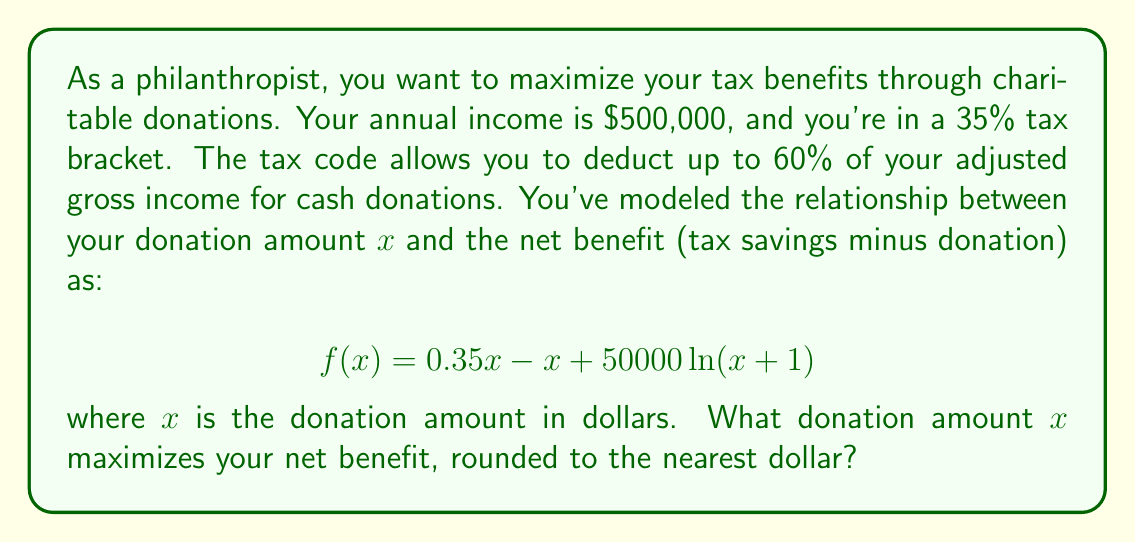Can you answer this question? To find the optimal donation amount, we need to maximize the function $f(x)$. This can be done by finding the value of $x$ where the derivative of $f(x)$ equals zero.

1) First, let's find the derivative of $f(x)$:
   $$ f'(x) = 0.35 - 1 + \frac{50000}{x+1} $$

2) Set the derivative equal to zero and solve for $x$:
   $$ 0.35 - 1 + \frac{50000}{x+1} = 0 $$
   $$ \frac{50000}{x+1} = 0.65 $$
   $$ 50000 = 0.65(x+1) $$
   $$ 76923.08 = x+1 $$
   $$ x = 75922.08 $$

3) To confirm this is a maximum, we can check the second derivative:
   $$ f''(x) = -\frac{50000}{(x+1)^2} $$
   This is always negative, confirming we have a maximum.

4) We need to check if this amount is within the allowable 60% of income:
   $$ 60\% \text{ of } \$500,000 = \$300,000 $$
   Our calculated optimal amount is less than this, so it's allowable.

5) Rounding to the nearest dollar gives us $75,922.
Answer: The optimal donation amount to maximize tax benefits is $75,922. 